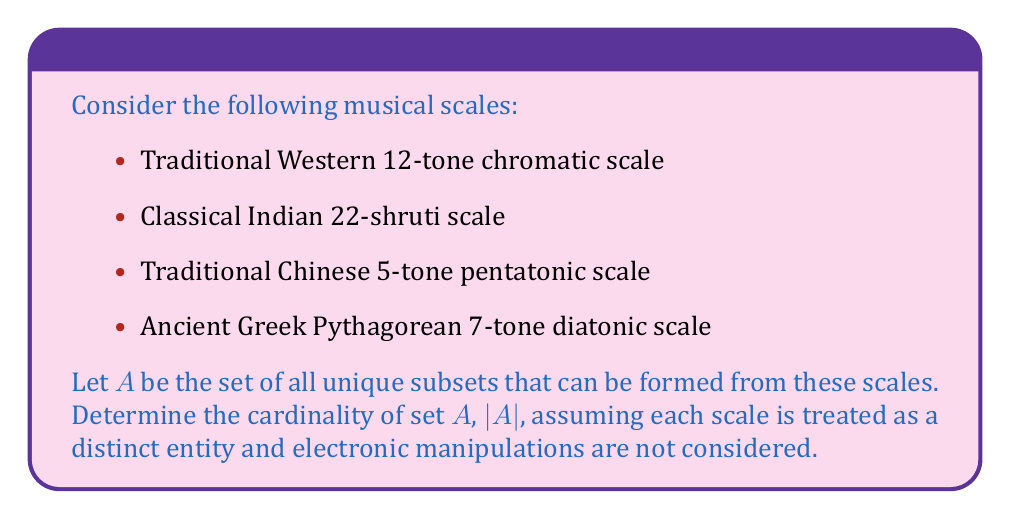Teach me how to tackle this problem. To solve this problem, we need to follow these steps:

1. Understand that we are dealing with the power set of the given scales.
2. Calculate the number of elements in the power set.
3. Subtract 1 from the result to exclude the empty set.

Step 1: The power set of a set S is the set of all subsets of S, including the empty set and S itself.

Step 2: For a set with n elements, the number of elements in its power set is $2^n$.

In this case, we have 4 distinct scales, so n = 4.

The number of elements in the power set is $2^4 = 16$.

Step 3: We subtract 1 to exclude the empty set, as it doesn't represent any musical scale.

Therefore, |A| = $2^4 - 1 = 16 - 1 = 15$

We can list these 15 subsets:
1. {Western 12-tone}
2. {Indian 22-shruti}
3. {Chinese 5-tone}
4. {Greek 7-tone}
5. {Western 12-tone, Indian 22-shruti}
6. {Western 12-tone, Chinese 5-tone}
7. {Western 12-tone, Greek 7-tone}
8. {Indian 22-shruti, Chinese 5-tone}
9. {Indian 22-shruti, Greek 7-tone}
10. {Chinese 5-tone, Greek 7-tone}
11. {Western 12-tone, Indian 22-shruti, Chinese 5-tone}
12. {Western 12-tone, Indian 22-shruti, Greek 7-tone}
13. {Western 12-tone, Chinese 5-tone, Greek 7-tone}
14. {Indian 22-shruti, Chinese 5-tone, Greek 7-tone}
15. {Western 12-tone, Indian 22-shruti, Chinese 5-tone, Greek 7-tone}

This approach respects the traditionalist perspective by treating each scale as a distinct, unaltered entity, without considering any electronic manipulations or combinations of individual notes from different scales.
Answer: $|A| = 15$ 